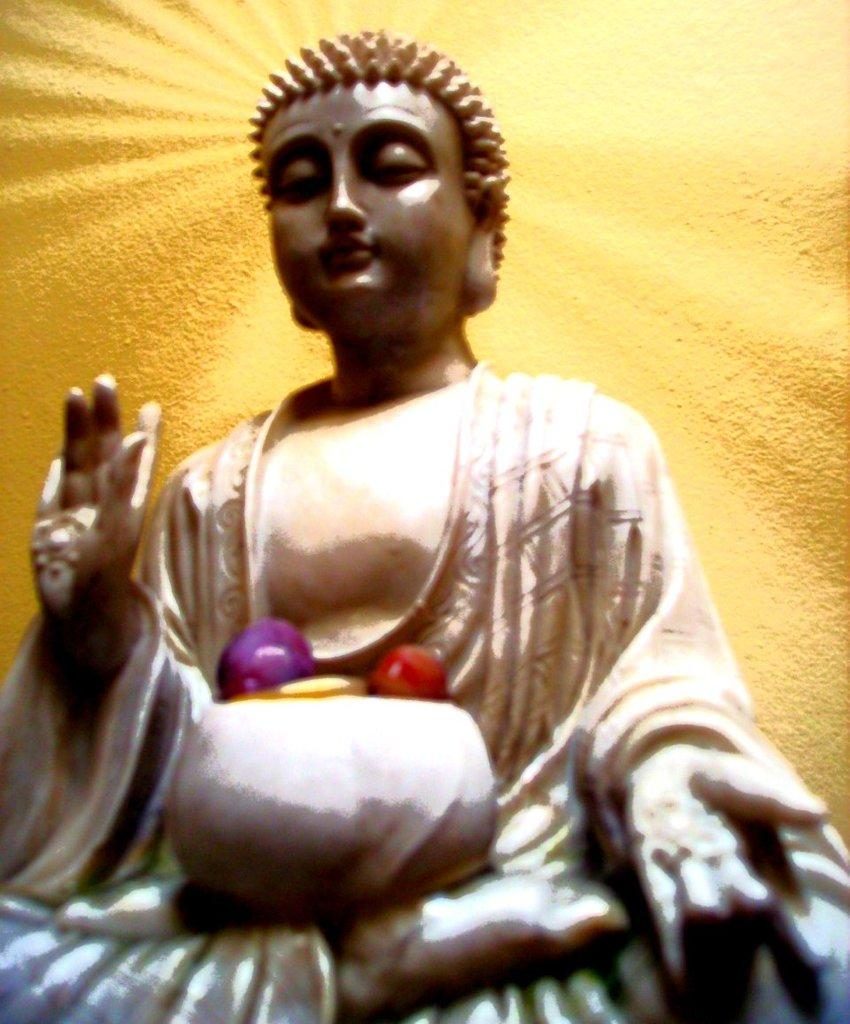What is the main subject in the image? There is a statue in the image. What can be seen in the background of the image? The background of the image is yellow. What type of experience does the statue have in the image? The statue is an inanimate object and does not have experiences. 